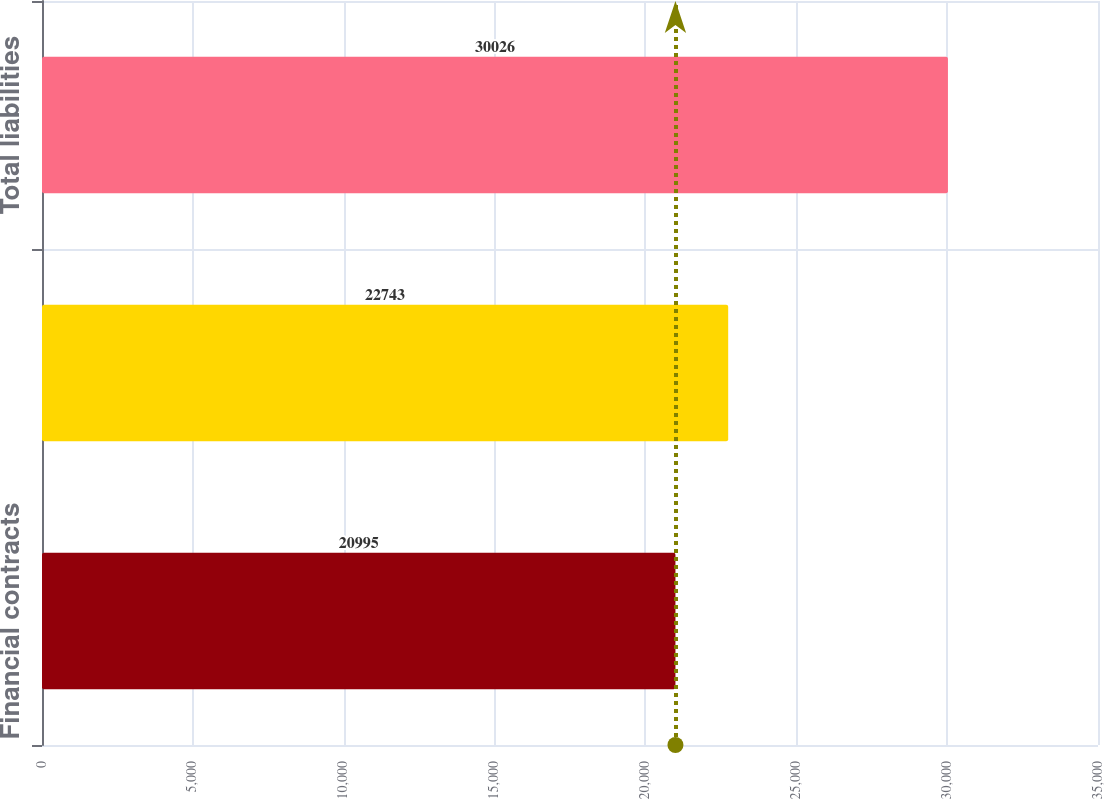Convert chart to OTSL. <chart><loc_0><loc_0><loc_500><loc_500><bar_chart><fcel>Financial contracts<fcel>Total derivatives<fcel>Total liabilities<nl><fcel>20995<fcel>22743<fcel>30026<nl></chart> 